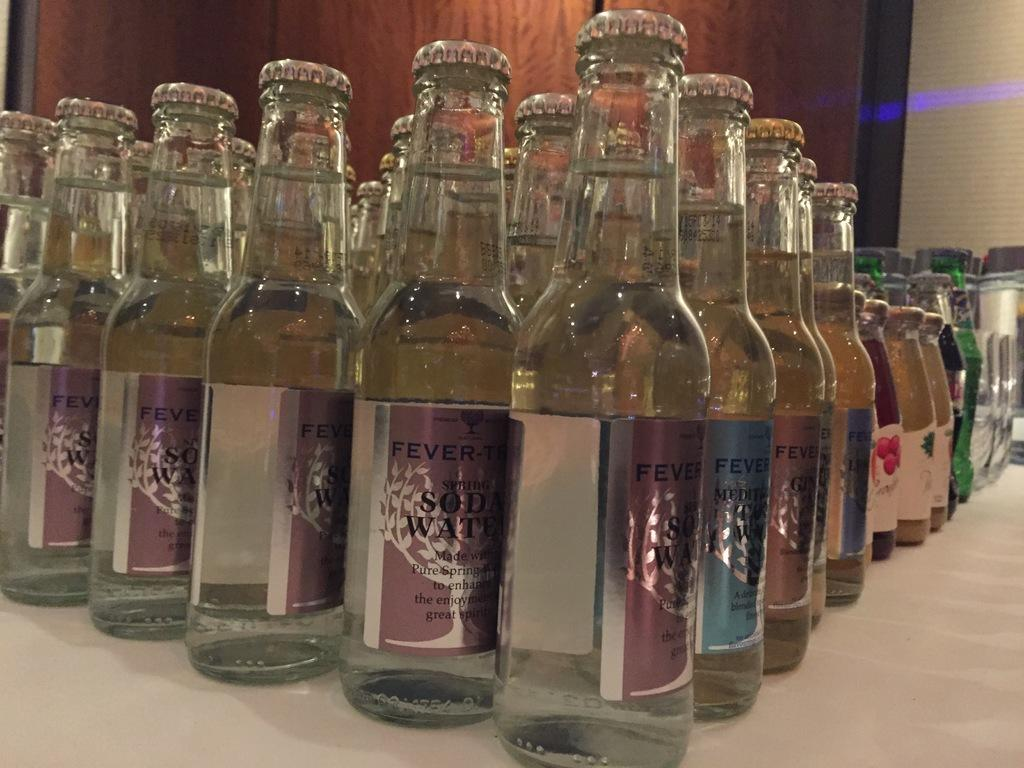<image>
Give a short and clear explanation of the subsequent image. Multiple Fever bottles stacked in front of one another. 